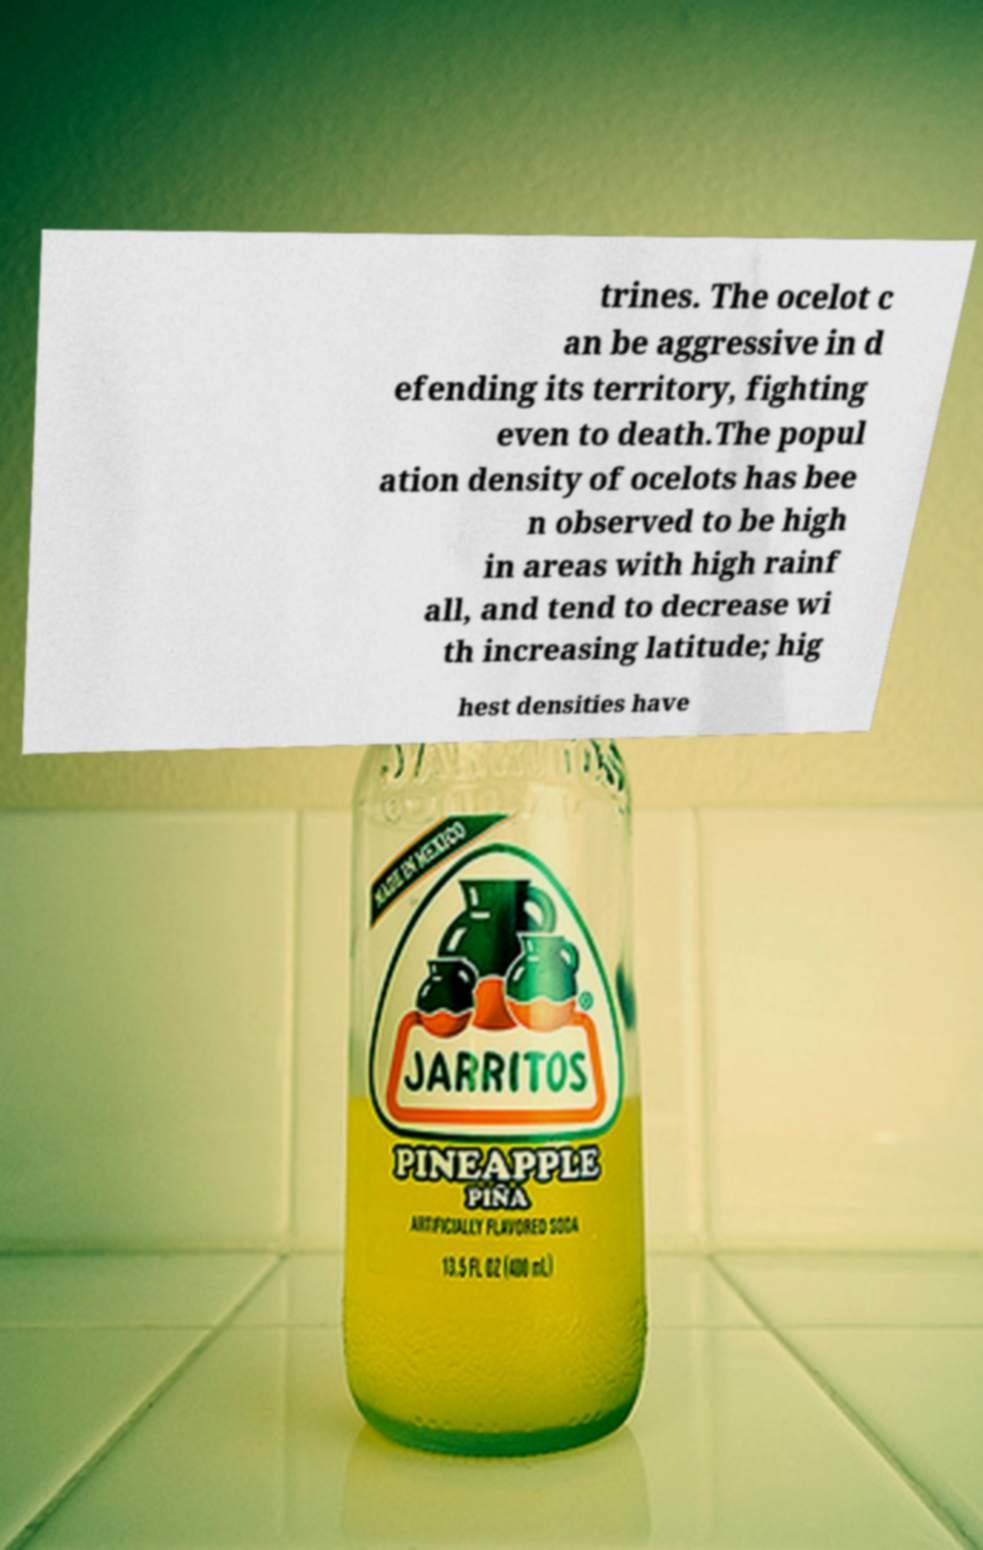Please identify and transcribe the text found in this image. trines. The ocelot c an be aggressive in d efending its territory, fighting even to death.The popul ation density of ocelots has bee n observed to be high in areas with high rainf all, and tend to decrease wi th increasing latitude; hig hest densities have 